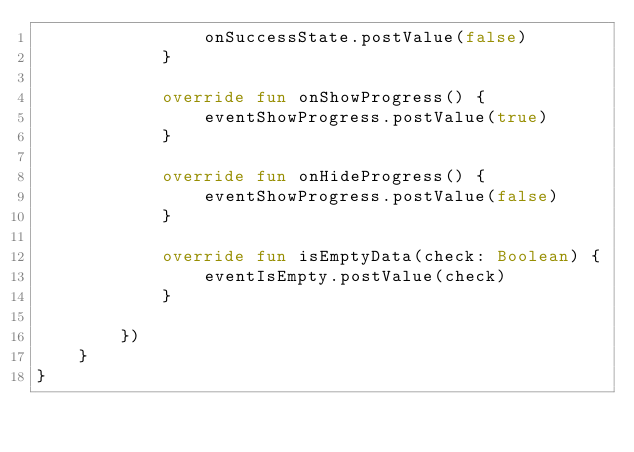<code> <loc_0><loc_0><loc_500><loc_500><_Kotlin_>                onSuccessState.postValue(false)
            }

            override fun onShowProgress() {
                eventShowProgress.postValue(true)
            }

            override fun onHideProgress() {
                eventShowProgress.postValue(false)
            }

            override fun isEmptyData(check: Boolean) {
                eventIsEmpty.postValue(check)
            }

        })
    }
}</code> 